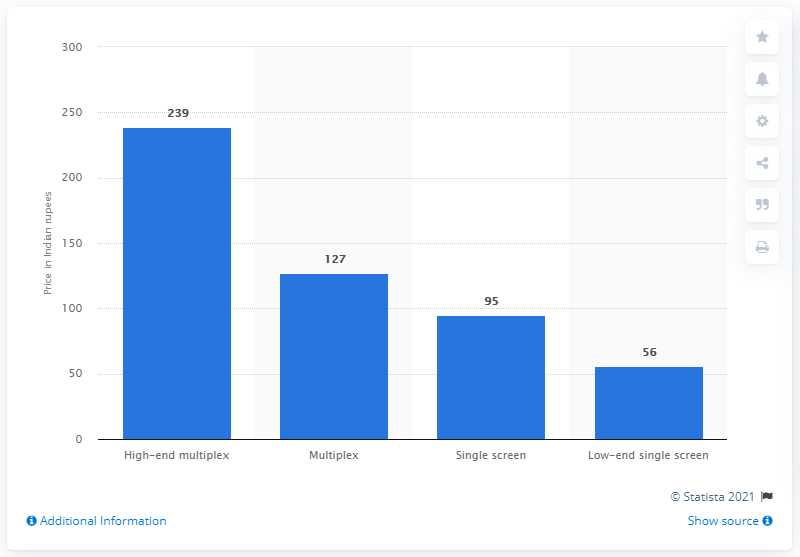Highlight a few significant elements in this photo. In 2013, the average price of a movie ticket in India was approximately 239 Indian rupees. 